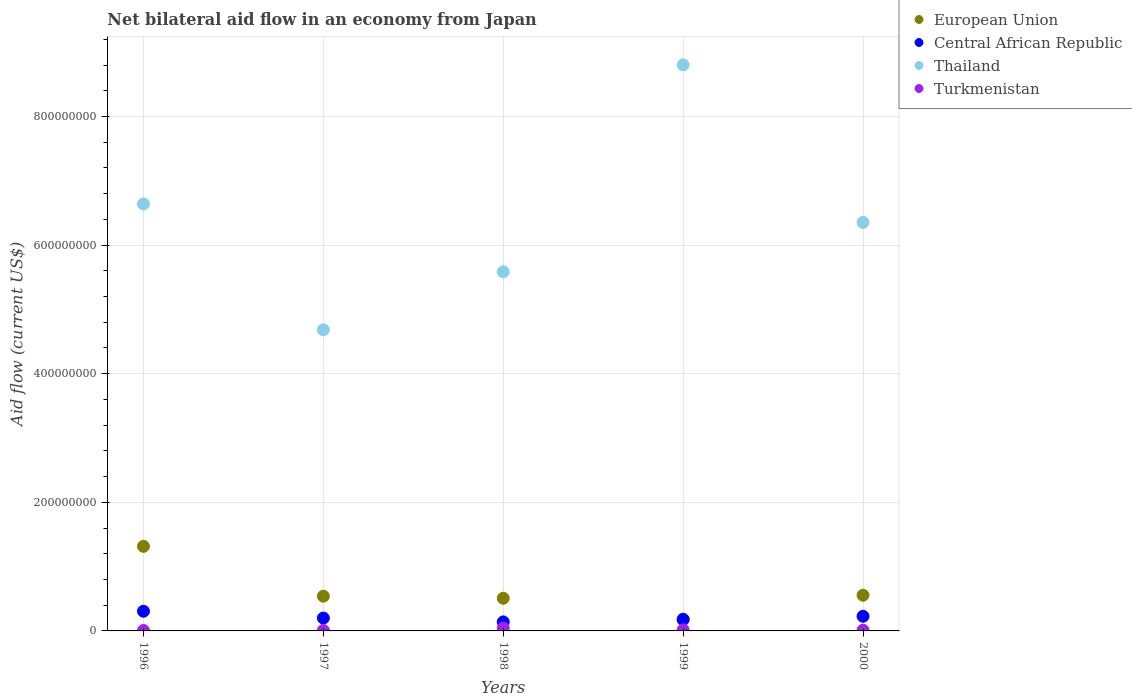What is the net bilateral aid flow in European Union in 1998?
Offer a very short reply. 5.08e+07. Across all years, what is the maximum net bilateral aid flow in European Union?
Provide a short and direct response. 1.32e+08. Across all years, what is the minimum net bilateral aid flow in Thailand?
Offer a very short reply. 4.68e+08. In which year was the net bilateral aid flow in Thailand maximum?
Offer a very short reply. 1999. In which year was the net bilateral aid flow in Thailand minimum?
Make the answer very short. 1997. What is the total net bilateral aid flow in Turkmenistan in the graph?
Offer a terse response. 8.61e+06. What is the difference between the net bilateral aid flow in Thailand in 1999 and that in 2000?
Offer a very short reply. 2.45e+08. What is the difference between the net bilateral aid flow in Central African Republic in 1998 and the net bilateral aid flow in European Union in 1999?
Your answer should be very brief. -3.07e+06. What is the average net bilateral aid flow in Central African Republic per year?
Your answer should be very brief. 2.11e+07. In the year 2000, what is the difference between the net bilateral aid flow in Central African Republic and net bilateral aid flow in European Union?
Provide a succinct answer. -3.27e+07. In how many years, is the net bilateral aid flow in Thailand greater than 160000000 US$?
Your answer should be very brief. 5. What is the ratio of the net bilateral aid flow in European Union in 1997 to that in 1998?
Keep it short and to the point. 1.06. Is the net bilateral aid flow in Turkmenistan in 1999 less than that in 2000?
Give a very brief answer. No. What is the difference between the highest and the second highest net bilateral aid flow in European Union?
Ensure brevity in your answer.  7.61e+07. What is the difference between the highest and the lowest net bilateral aid flow in European Union?
Provide a short and direct response. 1.14e+08. Is it the case that in every year, the sum of the net bilateral aid flow in Central African Republic and net bilateral aid flow in European Union  is greater than the net bilateral aid flow in Thailand?
Give a very brief answer. No. Does the graph contain any zero values?
Your answer should be compact. No. What is the title of the graph?
Your response must be concise. Net bilateral aid flow in an economy from Japan. Does "Kazakhstan" appear as one of the legend labels in the graph?
Keep it short and to the point. No. What is the Aid flow (current US$) of European Union in 1996?
Ensure brevity in your answer.  1.32e+08. What is the Aid flow (current US$) of Central African Republic in 1996?
Offer a very short reply. 3.06e+07. What is the Aid flow (current US$) in Thailand in 1996?
Your answer should be very brief. 6.64e+08. What is the Aid flow (current US$) in Turkmenistan in 1996?
Offer a terse response. 7.10e+05. What is the Aid flow (current US$) in European Union in 1997?
Your answer should be very brief. 5.40e+07. What is the Aid flow (current US$) of Central African Republic in 1997?
Your answer should be compact. 2.00e+07. What is the Aid flow (current US$) in Thailand in 1997?
Offer a terse response. 4.68e+08. What is the Aid flow (current US$) in Turkmenistan in 1997?
Keep it short and to the point. 7.80e+05. What is the Aid flow (current US$) in European Union in 1998?
Your answer should be very brief. 5.08e+07. What is the Aid flow (current US$) in Central African Republic in 1998?
Provide a short and direct response. 1.40e+07. What is the Aid flow (current US$) of Thailand in 1998?
Ensure brevity in your answer.  5.58e+08. What is the Aid flow (current US$) in Turkmenistan in 1998?
Your answer should be compact. 4.36e+06. What is the Aid flow (current US$) of European Union in 1999?
Provide a short and direct response. 1.71e+07. What is the Aid flow (current US$) in Central African Republic in 1999?
Your answer should be very brief. 1.81e+07. What is the Aid flow (current US$) in Thailand in 1999?
Keep it short and to the point. 8.80e+08. What is the Aid flow (current US$) in Turkmenistan in 1999?
Your response must be concise. 1.69e+06. What is the Aid flow (current US$) of European Union in 2000?
Provide a succinct answer. 5.55e+07. What is the Aid flow (current US$) of Central African Republic in 2000?
Give a very brief answer. 2.28e+07. What is the Aid flow (current US$) in Thailand in 2000?
Give a very brief answer. 6.35e+08. What is the Aid flow (current US$) of Turkmenistan in 2000?
Keep it short and to the point. 1.07e+06. Across all years, what is the maximum Aid flow (current US$) in European Union?
Your answer should be compact. 1.32e+08. Across all years, what is the maximum Aid flow (current US$) of Central African Republic?
Your response must be concise. 3.06e+07. Across all years, what is the maximum Aid flow (current US$) of Thailand?
Your answer should be compact. 8.80e+08. Across all years, what is the maximum Aid flow (current US$) of Turkmenistan?
Provide a succinct answer. 4.36e+06. Across all years, what is the minimum Aid flow (current US$) in European Union?
Offer a very short reply. 1.71e+07. Across all years, what is the minimum Aid flow (current US$) in Central African Republic?
Offer a very short reply. 1.40e+07. Across all years, what is the minimum Aid flow (current US$) in Thailand?
Keep it short and to the point. 4.68e+08. Across all years, what is the minimum Aid flow (current US$) in Turkmenistan?
Provide a succinct answer. 7.10e+05. What is the total Aid flow (current US$) of European Union in the graph?
Provide a short and direct response. 3.09e+08. What is the total Aid flow (current US$) of Central African Republic in the graph?
Keep it short and to the point. 1.05e+08. What is the total Aid flow (current US$) of Thailand in the graph?
Your answer should be compact. 3.21e+09. What is the total Aid flow (current US$) in Turkmenistan in the graph?
Your response must be concise. 8.61e+06. What is the difference between the Aid flow (current US$) of European Union in 1996 and that in 1997?
Provide a succinct answer. 7.76e+07. What is the difference between the Aid flow (current US$) of Central African Republic in 1996 and that in 1997?
Provide a short and direct response. 1.06e+07. What is the difference between the Aid flow (current US$) in Thailand in 1996 and that in 1997?
Your answer should be compact. 1.96e+08. What is the difference between the Aid flow (current US$) of Turkmenistan in 1996 and that in 1997?
Offer a terse response. -7.00e+04. What is the difference between the Aid flow (current US$) in European Union in 1996 and that in 1998?
Give a very brief answer. 8.08e+07. What is the difference between the Aid flow (current US$) in Central African Republic in 1996 and that in 1998?
Give a very brief answer. 1.66e+07. What is the difference between the Aid flow (current US$) in Thailand in 1996 and that in 1998?
Give a very brief answer. 1.06e+08. What is the difference between the Aid flow (current US$) of Turkmenistan in 1996 and that in 1998?
Provide a short and direct response. -3.65e+06. What is the difference between the Aid flow (current US$) in European Union in 1996 and that in 1999?
Keep it short and to the point. 1.14e+08. What is the difference between the Aid flow (current US$) in Central African Republic in 1996 and that in 1999?
Provide a short and direct response. 1.25e+07. What is the difference between the Aid flow (current US$) of Thailand in 1996 and that in 1999?
Provide a short and direct response. -2.16e+08. What is the difference between the Aid flow (current US$) in Turkmenistan in 1996 and that in 1999?
Offer a very short reply. -9.80e+05. What is the difference between the Aid flow (current US$) in European Union in 1996 and that in 2000?
Offer a terse response. 7.61e+07. What is the difference between the Aid flow (current US$) in Central African Republic in 1996 and that in 2000?
Your answer should be very brief. 7.86e+06. What is the difference between the Aid flow (current US$) in Thailand in 1996 and that in 2000?
Your answer should be very brief. 2.88e+07. What is the difference between the Aid flow (current US$) in Turkmenistan in 1996 and that in 2000?
Offer a terse response. -3.60e+05. What is the difference between the Aid flow (current US$) of European Union in 1997 and that in 1998?
Make the answer very short. 3.23e+06. What is the difference between the Aid flow (current US$) of Central African Republic in 1997 and that in 1998?
Make the answer very short. 5.97e+06. What is the difference between the Aid flow (current US$) in Thailand in 1997 and that in 1998?
Keep it short and to the point. -9.02e+07. What is the difference between the Aid flow (current US$) in Turkmenistan in 1997 and that in 1998?
Give a very brief answer. -3.58e+06. What is the difference between the Aid flow (current US$) of European Union in 1997 and that in 1999?
Keep it short and to the point. 3.69e+07. What is the difference between the Aid flow (current US$) of Central African Republic in 1997 and that in 1999?
Ensure brevity in your answer.  1.83e+06. What is the difference between the Aid flow (current US$) of Thailand in 1997 and that in 1999?
Provide a short and direct response. -4.12e+08. What is the difference between the Aid flow (current US$) in Turkmenistan in 1997 and that in 1999?
Your answer should be very brief. -9.10e+05. What is the difference between the Aid flow (current US$) in European Union in 1997 and that in 2000?
Your answer should be very brief. -1.46e+06. What is the difference between the Aid flow (current US$) in Central African Republic in 1997 and that in 2000?
Provide a short and direct response. -2.78e+06. What is the difference between the Aid flow (current US$) of Thailand in 1997 and that in 2000?
Provide a succinct answer. -1.67e+08. What is the difference between the Aid flow (current US$) in Turkmenistan in 1997 and that in 2000?
Make the answer very short. -2.90e+05. What is the difference between the Aid flow (current US$) of European Union in 1998 and that in 1999?
Your answer should be very brief. 3.37e+07. What is the difference between the Aid flow (current US$) in Central African Republic in 1998 and that in 1999?
Provide a succinct answer. -4.14e+06. What is the difference between the Aid flow (current US$) of Thailand in 1998 and that in 1999?
Ensure brevity in your answer.  -3.22e+08. What is the difference between the Aid flow (current US$) in Turkmenistan in 1998 and that in 1999?
Make the answer very short. 2.67e+06. What is the difference between the Aid flow (current US$) of European Union in 1998 and that in 2000?
Ensure brevity in your answer.  -4.69e+06. What is the difference between the Aid flow (current US$) in Central African Republic in 1998 and that in 2000?
Offer a very short reply. -8.75e+06. What is the difference between the Aid flow (current US$) of Thailand in 1998 and that in 2000?
Offer a very short reply. -7.68e+07. What is the difference between the Aid flow (current US$) of Turkmenistan in 1998 and that in 2000?
Provide a succinct answer. 3.29e+06. What is the difference between the Aid flow (current US$) in European Union in 1999 and that in 2000?
Your answer should be compact. -3.84e+07. What is the difference between the Aid flow (current US$) of Central African Republic in 1999 and that in 2000?
Your answer should be very brief. -4.61e+06. What is the difference between the Aid flow (current US$) of Thailand in 1999 and that in 2000?
Make the answer very short. 2.45e+08. What is the difference between the Aid flow (current US$) of Turkmenistan in 1999 and that in 2000?
Your response must be concise. 6.20e+05. What is the difference between the Aid flow (current US$) of European Union in 1996 and the Aid flow (current US$) of Central African Republic in 1997?
Offer a very short reply. 1.12e+08. What is the difference between the Aid flow (current US$) of European Union in 1996 and the Aid flow (current US$) of Thailand in 1997?
Provide a short and direct response. -3.37e+08. What is the difference between the Aid flow (current US$) in European Union in 1996 and the Aid flow (current US$) in Turkmenistan in 1997?
Give a very brief answer. 1.31e+08. What is the difference between the Aid flow (current US$) in Central African Republic in 1996 and the Aid flow (current US$) in Thailand in 1997?
Your answer should be very brief. -4.38e+08. What is the difference between the Aid flow (current US$) of Central African Republic in 1996 and the Aid flow (current US$) of Turkmenistan in 1997?
Your answer should be very brief. 2.98e+07. What is the difference between the Aid flow (current US$) of Thailand in 1996 and the Aid flow (current US$) of Turkmenistan in 1997?
Offer a terse response. 6.63e+08. What is the difference between the Aid flow (current US$) in European Union in 1996 and the Aid flow (current US$) in Central African Republic in 1998?
Keep it short and to the point. 1.18e+08. What is the difference between the Aid flow (current US$) of European Union in 1996 and the Aid flow (current US$) of Thailand in 1998?
Provide a succinct answer. -4.27e+08. What is the difference between the Aid flow (current US$) of European Union in 1996 and the Aid flow (current US$) of Turkmenistan in 1998?
Your response must be concise. 1.27e+08. What is the difference between the Aid flow (current US$) of Central African Republic in 1996 and the Aid flow (current US$) of Thailand in 1998?
Keep it short and to the point. -5.28e+08. What is the difference between the Aid flow (current US$) in Central African Republic in 1996 and the Aid flow (current US$) in Turkmenistan in 1998?
Your answer should be compact. 2.62e+07. What is the difference between the Aid flow (current US$) of Thailand in 1996 and the Aid flow (current US$) of Turkmenistan in 1998?
Give a very brief answer. 6.60e+08. What is the difference between the Aid flow (current US$) in European Union in 1996 and the Aid flow (current US$) in Central African Republic in 1999?
Make the answer very short. 1.13e+08. What is the difference between the Aid flow (current US$) of European Union in 1996 and the Aid flow (current US$) of Thailand in 1999?
Keep it short and to the point. -7.49e+08. What is the difference between the Aid flow (current US$) in European Union in 1996 and the Aid flow (current US$) in Turkmenistan in 1999?
Give a very brief answer. 1.30e+08. What is the difference between the Aid flow (current US$) of Central African Republic in 1996 and the Aid flow (current US$) of Thailand in 1999?
Make the answer very short. -8.50e+08. What is the difference between the Aid flow (current US$) of Central African Republic in 1996 and the Aid flow (current US$) of Turkmenistan in 1999?
Make the answer very short. 2.89e+07. What is the difference between the Aid flow (current US$) in Thailand in 1996 and the Aid flow (current US$) in Turkmenistan in 1999?
Ensure brevity in your answer.  6.62e+08. What is the difference between the Aid flow (current US$) of European Union in 1996 and the Aid flow (current US$) of Central African Republic in 2000?
Provide a succinct answer. 1.09e+08. What is the difference between the Aid flow (current US$) of European Union in 1996 and the Aid flow (current US$) of Thailand in 2000?
Ensure brevity in your answer.  -5.04e+08. What is the difference between the Aid flow (current US$) in European Union in 1996 and the Aid flow (current US$) in Turkmenistan in 2000?
Give a very brief answer. 1.30e+08. What is the difference between the Aid flow (current US$) of Central African Republic in 1996 and the Aid flow (current US$) of Thailand in 2000?
Offer a terse response. -6.05e+08. What is the difference between the Aid flow (current US$) in Central African Republic in 1996 and the Aid flow (current US$) in Turkmenistan in 2000?
Offer a terse response. 2.95e+07. What is the difference between the Aid flow (current US$) in Thailand in 1996 and the Aid flow (current US$) in Turkmenistan in 2000?
Provide a short and direct response. 6.63e+08. What is the difference between the Aid flow (current US$) in European Union in 1997 and the Aid flow (current US$) in Central African Republic in 1998?
Ensure brevity in your answer.  4.00e+07. What is the difference between the Aid flow (current US$) of European Union in 1997 and the Aid flow (current US$) of Thailand in 1998?
Your response must be concise. -5.04e+08. What is the difference between the Aid flow (current US$) in European Union in 1997 and the Aid flow (current US$) in Turkmenistan in 1998?
Provide a succinct answer. 4.96e+07. What is the difference between the Aid flow (current US$) of Central African Republic in 1997 and the Aid flow (current US$) of Thailand in 1998?
Your response must be concise. -5.38e+08. What is the difference between the Aid flow (current US$) in Central African Republic in 1997 and the Aid flow (current US$) in Turkmenistan in 1998?
Make the answer very short. 1.56e+07. What is the difference between the Aid flow (current US$) in Thailand in 1997 and the Aid flow (current US$) in Turkmenistan in 1998?
Offer a terse response. 4.64e+08. What is the difference between the Aid flow (current US$) of European Union in 1997 and the Aid flow (current US$) of Central African Republic in 1999?
Ensure brevity in your answer.  3.59e+07. What is the difference between the Aid flow (current US$) of European Union in 1997 and the Aid flow (current US$) of Thailand in 1999?
Provide a succinct answer. -8.26e+08. What is the difference between the Aid flow (current US$) of European Union in 1997 and the Aid flow (current US$) of Turkmenistan in 1999?
Offer a terse response. 5.23e+07. What is the difference between the Aid flow (current US$) of Central African Republic in 1997 and the Aid flow (current US$) of Thailand in 1999?
Your answer should be very brief. -8.60e+08. What is the difference between the Aid flow (current US$) of Central African Republic in 1997 and the Aid flow (current US$) of Turkmenistan in 1999?
Your answer should be compact. 1.83e+07. What is the difference between the Aid flow (current US$) of Thailand in 1997 and the Aid flow (current US$) of Turkmenistan in 1999?
Your answer should be very brief. 4.67e+08. What is the difference between the Aid flow (current US$) of European Union in 1997 and the Aid flow (current US$) of Central African Republic in 2000?
Your answer should be very brief. 3.13e+07. What is the difference between the Aid flow (current US$) in European Union in 1997 and the Aid flow (current US$) in Thailand in 2000?
Offer a very short reply. -5.81e+08. What is the difference between the Aid flow (current US$) in European Union in 1997 and the Aid flow (current US$) in Turkmenistan in 2000?
Keep it short and to the point. 5.29e+07. What is the difference between the Aid flow (current US$) in Central African Republic in 1997 and the Aid flow (current US$) in Thailand in 2000?
Provide a succinct answer. -6.15e+08. What is the difference between the Aid flow (current US$) of Central African Republic in 1997 and the Aid flow (current US$) of Turkmenistan in 2000?
Offer a very short reply. 1.89e+07. What is the difference between the Aid flow (current US$) in Thailand in 1997 and the Aid flow (current US$) in Turkmenistan in 2000?
Make the answer very short. 4.67e+08. What is the difference between the Aid flow (current US$) in European Union in 1998 and the Aid flow (current US$) in Central African Republic in 1999?
Provide a succinct answer. 3.26e+07. What is the difference between the Aid flow (current US$) in European Union in 1998 and the Aid flow (current US$) in Thailand in 1999?
Offer a terse response. -8.29e+08. What is the difference between the Aid flow (current US$) of European Union in 1998 and the Aid flow (current US$) of Turkmenistan in 1999?
Offer a terse response. 4.91e+07. What is the difference between the Aid flow (current US$) in Central African Republic in 1998 and the Aid flow (current US$) in Thailand in 1999?
Your answer should be compact. -8.66e+08. What is the difference between the Aid flow (current US$) of Central African Republic in 1998 and the Aid flow (current US$) of Turkmenistan in 1999?
Your response must be concise. 1.23e+07. What is the difference between the Aid flow (current US$) in Thailand in 1998 and the Aid flow (current US$) in Turkmenistan in 1999?
Provide a short and direct response. 5.57e+08. What is the difference between the Aid flow (current US$) of European Union in 1998 and the Aid flow (current US$) of Central African Republic in 2000?
Offer a very short reply. 2.80e+07. What is the difference between the Aid flow (current US$) of European Union in 1998 and the Aid flow (current US$) of Thailand in 2000?
Offer a terse response. -5.84e+08. What is the difference between the Aid flow (current US$) of European Union in 1998 and the Aid flow (current US$) of Turkmenistan in 2000?
Offer a very short reply. 4.97e+07. What is the difference between the Aid flow (current US$) in Central African Republic in 1998 and the Aid flow (current US$) in Thailand in 2000?
Keep it short and to the point. -6.21e+08. What is the difference between the Aid flow (current US$) in Central African Republic in 1998 and the Aid flow (current US$) in Turkmenistan in 2000?
Your response must be concise. 1.29e+07. What is the difference between the Aid flow (current US$) of Thailand in 1998 and the Aid flow (current US$) of Turkmenistan in 2000?
Offer a terse response. 5.57e+08. What is the difference between the Aid flow (current US$) in European Union in 1999 and the Aid flow (current US$) in Central African Republic in 2000?
Provide a short and direct response. -5.68e+06. What is the difference between the Aid flow (current US$) of European Union in 1999 and the Aid flow (current US$) of Thailand in 2000?
Offer a terse response. -6.18e+08. What is the difference between the Aid flow (current US$) of European Union in 1999 and the Aid flow (current US$) of Turkmenistan in 2000?
Keep it short and to the point. 1.60e+07. What is the difference between the Aid flow (current US$) of Central African Republic in 1999 and the Aid flow (current US$) of Thailand in 2000?
Offer a terse response. -6.17e+08. What is the difference between the Aid flow (current US$) of Central African Republic in 1999 and the Aid flow (current US$) of Turkmenistan in 2000?
Offer a terse response. 1.71e+07. What is the difference between the Aid flow (current US$) in Thailand in 1999 and the Aid flow (current US$) in Turkmenistan in 2000?
Your answer should be very brief. 8.79e+08. What is the average Aid flow (current US$) of European Union per year?
Offer a very short reply. 6.18e+07. What is the average Aid flow (current US$) in Central African Republic per year?
Your answer should be very brief. 2.11e+07. What is the average Aid flow (current US$) in Thailand per year?
Your answer should be very brief. 6.41e+08. What is the average Aid flow (current US$) of Turkmenistan per year?
Give a very brief answer. 1.72e+06. In the year 1996, what is the difference between the Aid flow (current US$) in European Union and Aid flow (current US$) in Central African Republic?
Keep it short and to the point. 1.01e+08. In the year 1996, what is the difference between the Aid flow (current US$) of European Union and Aid flow (current US$) of Thailand?
Give a very brief answer. -5.32e+08. In the year 1996, what is the difference between the Aid flow (current US$) in European Union and Aid flow (current US$) in Turkmenistan?
Keep it short and to the point. 1.31e+08. In the year 1996, what is the difference between the Aid flow (current US$) of Central African Republic and Aid flow (current US$) of Thailand?
Your answer should be compact. -6.33e+08. In the year 1996, what is the difference between the Aid flow (current US$) in Central African Republic and Aid flow (current US$) in Turkmenistan?
Provide a short and direct response. 2.99e+07. In the year 1996, what is the difference between the Aid flow (current US$) in Thailand and Aid flow (current US$) in Turkmenistan?
Provide a short and direct response. 6.63e+08. In the year 1997, what is the difference between the Aid flow (current US$) in European Union and Aid flow (current US$) in Central African Republic?
Keep it short and to the point. 3.40e+07. In the year 1997, what is the difference between the Aid flow (current US$) in European Union and Aid flow (current US$) in Thailand?
Make the answer very short. -4.14e+08. In the year 1997, what is the difference between the Aid flow (current US$) of European Union and Aid flow (current US$) of Turkmenistan?
Make the answer very short. 5.32e+07. In the year 1997, what is the difference between the Aid flow (current US$) of Central African Republic and Aid flow (current US$) of Thailand?
Keep it short and to the point. -4.48e+08. In the year 1997, what is the difference between the Aid flow (current US$) in Central African Republic and Aid flow (current US$) in Turkmenistan?
Your response must be concise. 1.92e+07. In the year 1997, what is the difference between the Aid flow (current US$) in Thailand and Aid flow (current US$) in Turkmenistan?
Provide a short and direct response. 4.67e+08. In the year 1998, what is the difference between the Aid flow (current US$) of European Union and Aid flow (current US$) of Central African Republic?
Offer a very short reply. 3.68e+07. In the year 1998, what is the difference between the Aid flow (current US$) of European Union and Aid flow (current US$) of Thailand?
Give a very brief answer. -5.08e+08. In the year 1998, what is the difference between the Aid flow (current US$) of European Union and Aid flow (current US$) of Turkmenistan?
Your answer should be compact. 4.64e+07. In the year 1998, what is the difference between the Aid flow (current US$) in Central African Republic and Aid flow (current US$) in Thailand?
Keep it short and to the point. -5.44e+08. In the year 1998, what is the difference between the Aid flow (current US$) of Central African Republic and Aid flow (current US$) of Turkmenistan?
Your response must be concise. 9.64e+06. In the year 1998, what is the difference between the Aid flow (current US$) of Thailand and Aid flow (current US$) of Turkmenistan?
Your answer should be compact. 5.54e+08. In the year 1999, what is the difference between the Aid flow (current US$) of European Union and Aid flow (current US$) of Central African Republic?
Offer a very short reply. -1.07e+06. In the year 1999, what is the difference between the Aid flow (current US$) of European Union and Aid flow (current US$) of Thailand?
Provide a succinct answer. -8.63e+08. In the year 1999, what is the difference between the Aid flow (current US$) of European Union and Aid flow (current US$) of Turkmenistan?
Give a very brief answer. 1.54e+07. In the year 1999, what is the difference between the Aid flow (current US$) of Central African Republic and Aid flow (current US$) of Thailand?
Your answer should be compact. -8.62e+08. In the year 1999, what is the difference between the Aid flow (current US$) in Central African Republic and Aid flow (current US$) in Turkmenistan?
Your response must be concise. 1.64e+07. In the year 1999, what is the difference between the Aid flow (current US$) in Thailand and Aid flow (current US$) in Turkmenistan?
Your response must be concise. 8.79e+08. In the year 2000, what is the difference between the Aid flow (current US$) in European Union and Aid flow (current US$) in Central African Republic?
Your answer should be compact. 3.27e+07. In the year 2000, what is the difference between the Aid flow (current US$) of European Union and Aid flow (current US$) of Thailand?
Make the answer very short. -5.80e+08. In the year 2000, what is the difference between the Aid flow (current US$) of European Union and Aid flow (current US$) of Turkmenistan?
Give a very brief answer. 5.44e+07. In the year 2000, what is the difference between the Aid flow (current US$) of Central African Republic and Aid flow (current US$) of Thailand?
Your answer should be compact. -6.12e+08. In the year 2000, what is the difference between the Aid flow (current US$) of Central African Republic and Aid flow (current US$) of Turkmenistan?
Your response must be concise. 2.17e+07. In the year 2000, what is the difference between the Aid flow (current US$) of Thailand and Aid flow (current US$) of Turkmenistan?
Ensure brevity in your answer.  6.34e+08. What is the ratio of the Aid flow (current US$) in European Union in 1996 to that in 1997?
Ensure brevity in your answer.  2.44. What is the ratio of the Aid flow (current US$) of Central African Republic in 1996 to that in 1997?
Ensure brevity in your answer.  1.53. What is the ratio of the Aid flow (current US$) of Thailand in 1996 to that in 1997?
Give a very brief answer. 1.42. What is the ratio of the Aid flow (current US$) in Turkmenistan in 1996 to that in 1997?
Your response must be concise. 0.91. What is the ratio of the Aid flow (current US$) of European Union in 1996 to that in 1998?
Keep it short and to the point. 2.59. What is the ratio of the Aid flow (current US$) of Central African Republic in 1996 to that in 1998?
Offer a terse response. 2.19. What is the ratio of the Aid flow (current US$) of Thailand in 1996 to that in 1998?
Your answer should be compact. 1.19. What is the ratio of the Aid flow (current US$) of Turkmenistan in 1996 to that in 1998?
Your answer should be very brief. 0.16. What is the ratio of the Aid flow (current US$) of European Union in 1996 to that in 1999?
Provide a short and direct response. 7.71. What is the ratio of the Aid flow (current US$) in Central African Republic in 1996 to that in 1999?
Ensure brevity in your answer.  1.69. What is the ratio of the Aid flow (current US$) of Thailand in 1996 to that in 1999?
Offer a terse response. 0.75. What is the ratio of the Aid flow (current US$) of Turkmenistan in 1996 to that in 1999?
Provide a succinct answer. 0.42. What is the ratio of the Aid flow (current US$) of European Union in 1996 to that in 2000?
Your answer should be very brief. 2.37. What is the ratio of the Aid flow (current US$) of Central African Republic in 1996 to that in 2000?
Ensure brevity in your answer.  1.35. What is the ratio of the Aid flow (current US$) in Thailand in 1996 to that in 2000?
Offer a terse response. 1.05. What is the ratio of the Aid flow (current US$) of Turkmenistan in 1996 to that in 2000?
Offer a terse response. 0.66. What is the ratio of the Aid flow (current US$) in European Union in 1997 to that in 1998?
Your response must be concise. 1.06. What is the ratio of the Aid flow (current US$) in Central African Republic in 1997 to that in 1998?
Make the answer very short. 1.43. What is the ratio of the Aid flow (current US$) in Thailand in 1997 to that in 1998?
Your response must be concise. 0.84. What is the ratio of the Aid flow (current US$) of Turkmenistan in 1997 to that in 1998?
Ensure brevity in your answer.  0.18. What is the ratio of the Aid flow (current US$) in European Union in 1997 to that in 1999?
Keep it short and to the point. 3.16. What is the ratio of the Aid flow (current US$) in Central African Republic in 1997 to that in 1999?
Provide a short and direct response. 1.1. What is the ratio of the Aid flow (current US$) of Thailand in 1997 to that in 1999?
Provide a succinct answer. 0.53. What is the ratio of the Aid flow (current US$) in Turkmenistan in 1997 to that in 1999?
Ensure brevity in your answer.  0.46. What is the ratio of the Aid flow (current US$) of European Union in 1997 to that in 2000?
Your answer should be very brief. 0.97. What is the ratio of the Aid flow (current US$) of Central African Republic in 1997 to that in 2000?
Ensure brevity in your answer.  0.88. What is the ratio of the Aid flow (current US$) of Thailand in 1997 to that in 2000?
Keep it short and to the point. 0.74. What is the ratio of the Aid flow (current US$) of Turkmenistan in 1997 to that in 2000?
Provide a succinct answer. 0.73. What is the ratio of the Aid flow (current US$) in European Union in 1998 to that in 1999?
Keep it short and to the point. 2.97. What is the ratio of the Aid flow (current US$) of Central African Republic in 1998 to that in 1999?
Your response must be concise. 0.77. What is the ratio of the Aid flow (current US$) of Thailand in 1998 to that in 1999?
Give a very brief answer. 0.63. What is the ratio of the Aid flow (current US$) in Turkmenistan in 1998 to that in 1999?
Offer a terse response. 2.58. What is the ratio of the Aid flow (current US$) of European Union in 1998 to that in 2000?
Give a very brief answer. 0.92. What is the ratio of the Aid flow (current US$) of Central African Republic in 1998 to that in 2000?
Ensure brevity in your answer.  0.62. What is the ratio of the Aid flow (current US$) in Thailand in 1998 to that in 2000?
Keep it short and to the point. 0.88. What is the ratio of the Aid flow (current US$) of Turkmenistan in 1998 to that in 2000?
Your answer should be very brief. 4.07. What is the ratio of the Aid flow (current US$) of European Union in 1999 to that in 2000?
Make the answer very short. 0.31. What is the ratio of the Aid flow (current US$) of Central African Republic in 1999 to that in 2000?
Your answer should be compact. 0.8. What is the ratio of the Aid flow (current US$) in Thailand in 1999 to that in 2000?
Offer a very short reply. 1.39. What is the ratio of the Aid flow (current US$) in Turkmenistan in 1999 to that in 2000?
Ensure brevity in your answer.  1.58. What is the difference between the highest and the second highest Aid flow (current US$) in European Union?
Keep it short and to the point. 7.61e+07. What is the difference between the highest and the second highest Aid flow (current US$) in Central African Republic?
Your answer should be very brief. 7.86e+06. What is the difference between the highest and the second highest Aid flow (current US$) of Thailand?
Keep it short and to the point. 2.16e+08. What is the difference between the highest and the second highest Aid flow (current US$) of Turkmenistan?
Offer a very short reply. 2.67e+06. What is the difference between the highest and the lowest Aid flow (current US$) in European Union?
Offer a very short reply. 1.14e+08. What is the difference between the highest and the lowest Aid flow (current US$) of Central African Republic?
Keep it short and to the point. 1.66e+07. What is the difference between the highest and the lowest Aid flow (current US$) of Thailand?
Ensure brevity in your answer.  4.12e+08. What is the difference between the highest and the lowest Aid flow (current US$) of Turkmenistan?
Your answer should be very brief. 3.65e+06. 